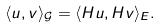<formula> <loc_0><loc_0><loc_500><loc_500>\langle u , v \rangle _ { \mathcal { G } } = \langle H u , H v \rangle _ { E } .</formula> 